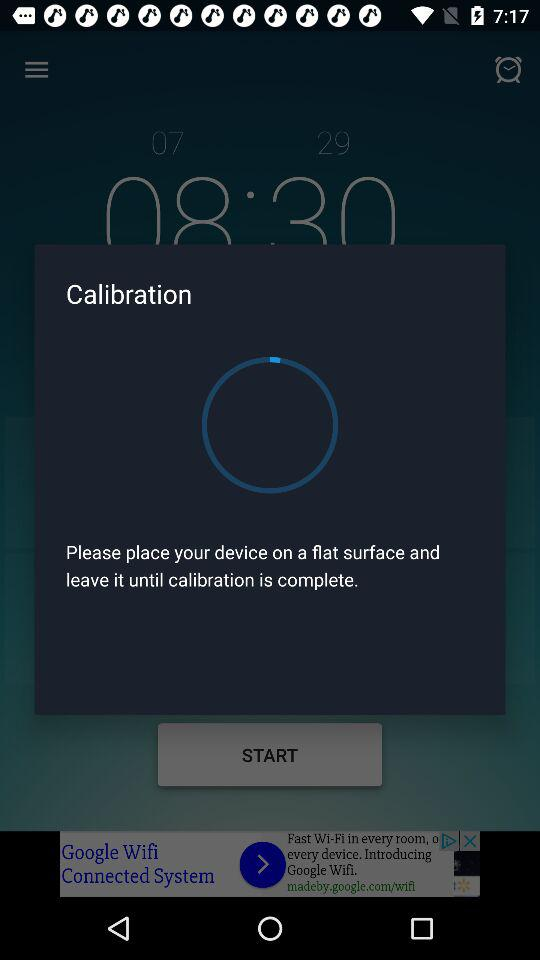What is the sleep duration? The sleep duration is 7 hours and 52 minutes. 